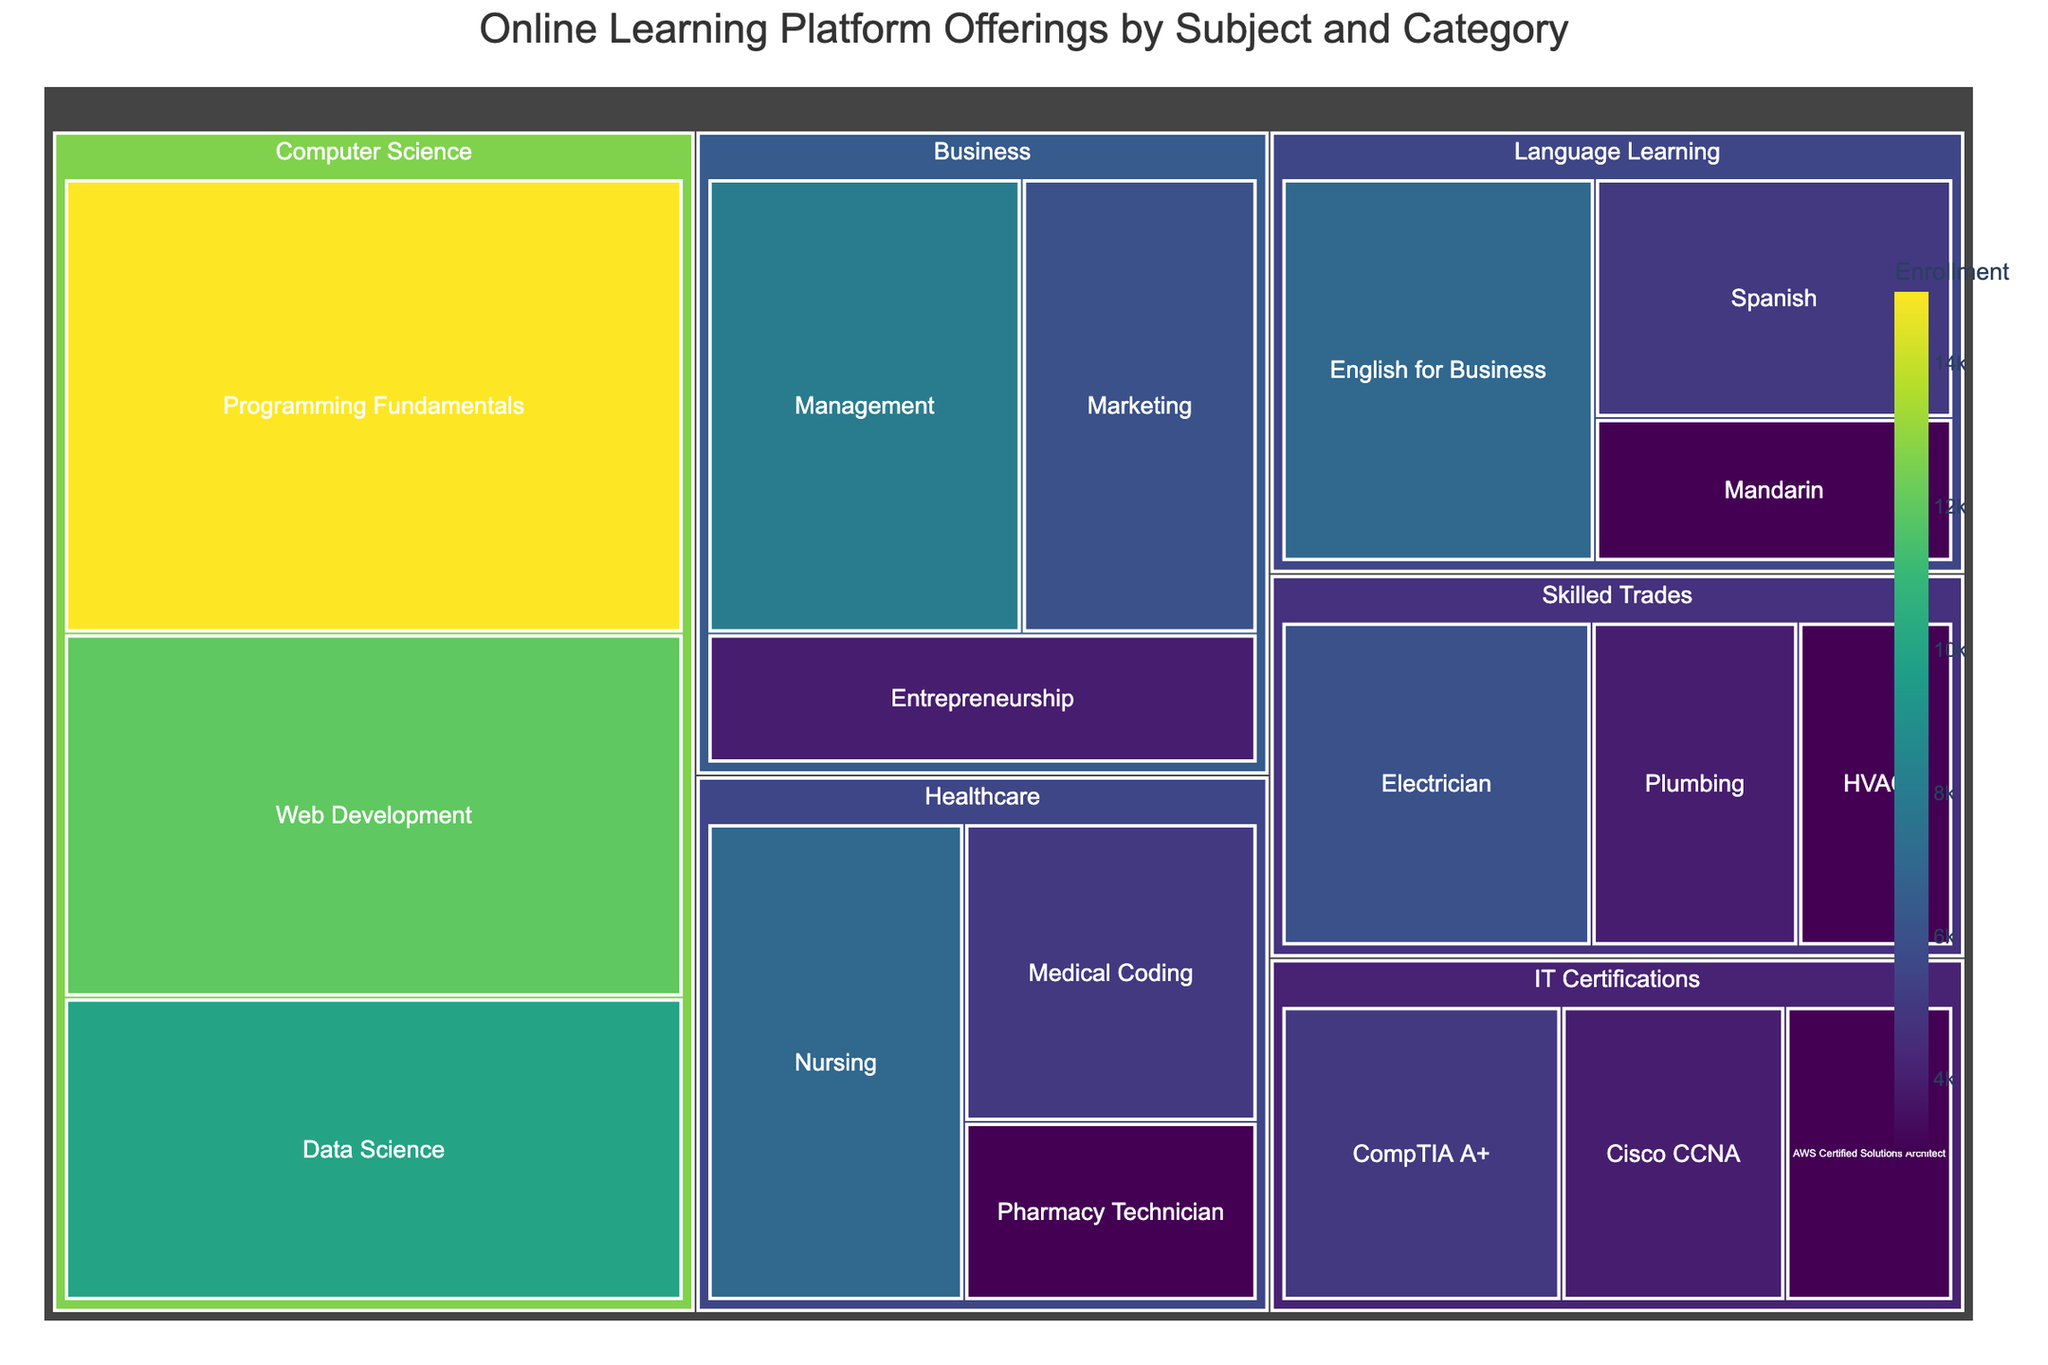What's the title of the treemap? The title of the treemap is usually displayed at the top of the figure and summarizes the main content shown.
Answer: Online Learning Platform Offerings by Subject and Category How many main subject areas are displayed in the treemap? Count the number of unique large boxes in the treemap, each representing a main subject area.
Answer: 6 Which subject area has the highest overall enrollment? Look at the relative size of the large boxes; the largest one indicates the highest enrollment.
Answer: Computer Science What is the enrollment for the Programming Fundamentals category within Computer Science? Find the box labeled "Programming Fundamentals" under Computer Science and note the enrollment value displayed.
Answer: 15000 How does enrollment for Web Development compare to Data Science within Computer Science? Compare the sizes or the exact enrollment numbers of the Web Development and Data Science categories within the Computer Science subject area.
Answer: Web Development has a higher enrollment (12000 vs 10000) What’s the total enrollment for all IT Certifications categories combined? Sum up the enrollment numbers for CompTIA A+, Cisco CCNA, and AWS Certified Solutions Architect.
Answer: 12000 Which category in the Skilled Trades subject area has the lowest enrollment? Identify the category in Skilled Trades with the smallest box or lowest number.
Answer: HVAC What's the difference in enrollment between Nursing and Medical Coding within Healthcare? Subtract the enrollment number of Medical Coding from Nursing.
Answer: 2000 What unique color characteristics can you observe in this treemap? Describe the color scheme used and how it is applied to the boxes based on enrollment numbers.
Answer: The treemap uses a continuous color scale from light to dark green, where darker shades represent higher enrollments Compare the total enrollment in Business to that in Healthcare. Which one has higher overall enrollment? Sum the enrollment numbers for categories in both Business and Healthcare, then compare the totals.
Answer: Business has higher overall enrollment 